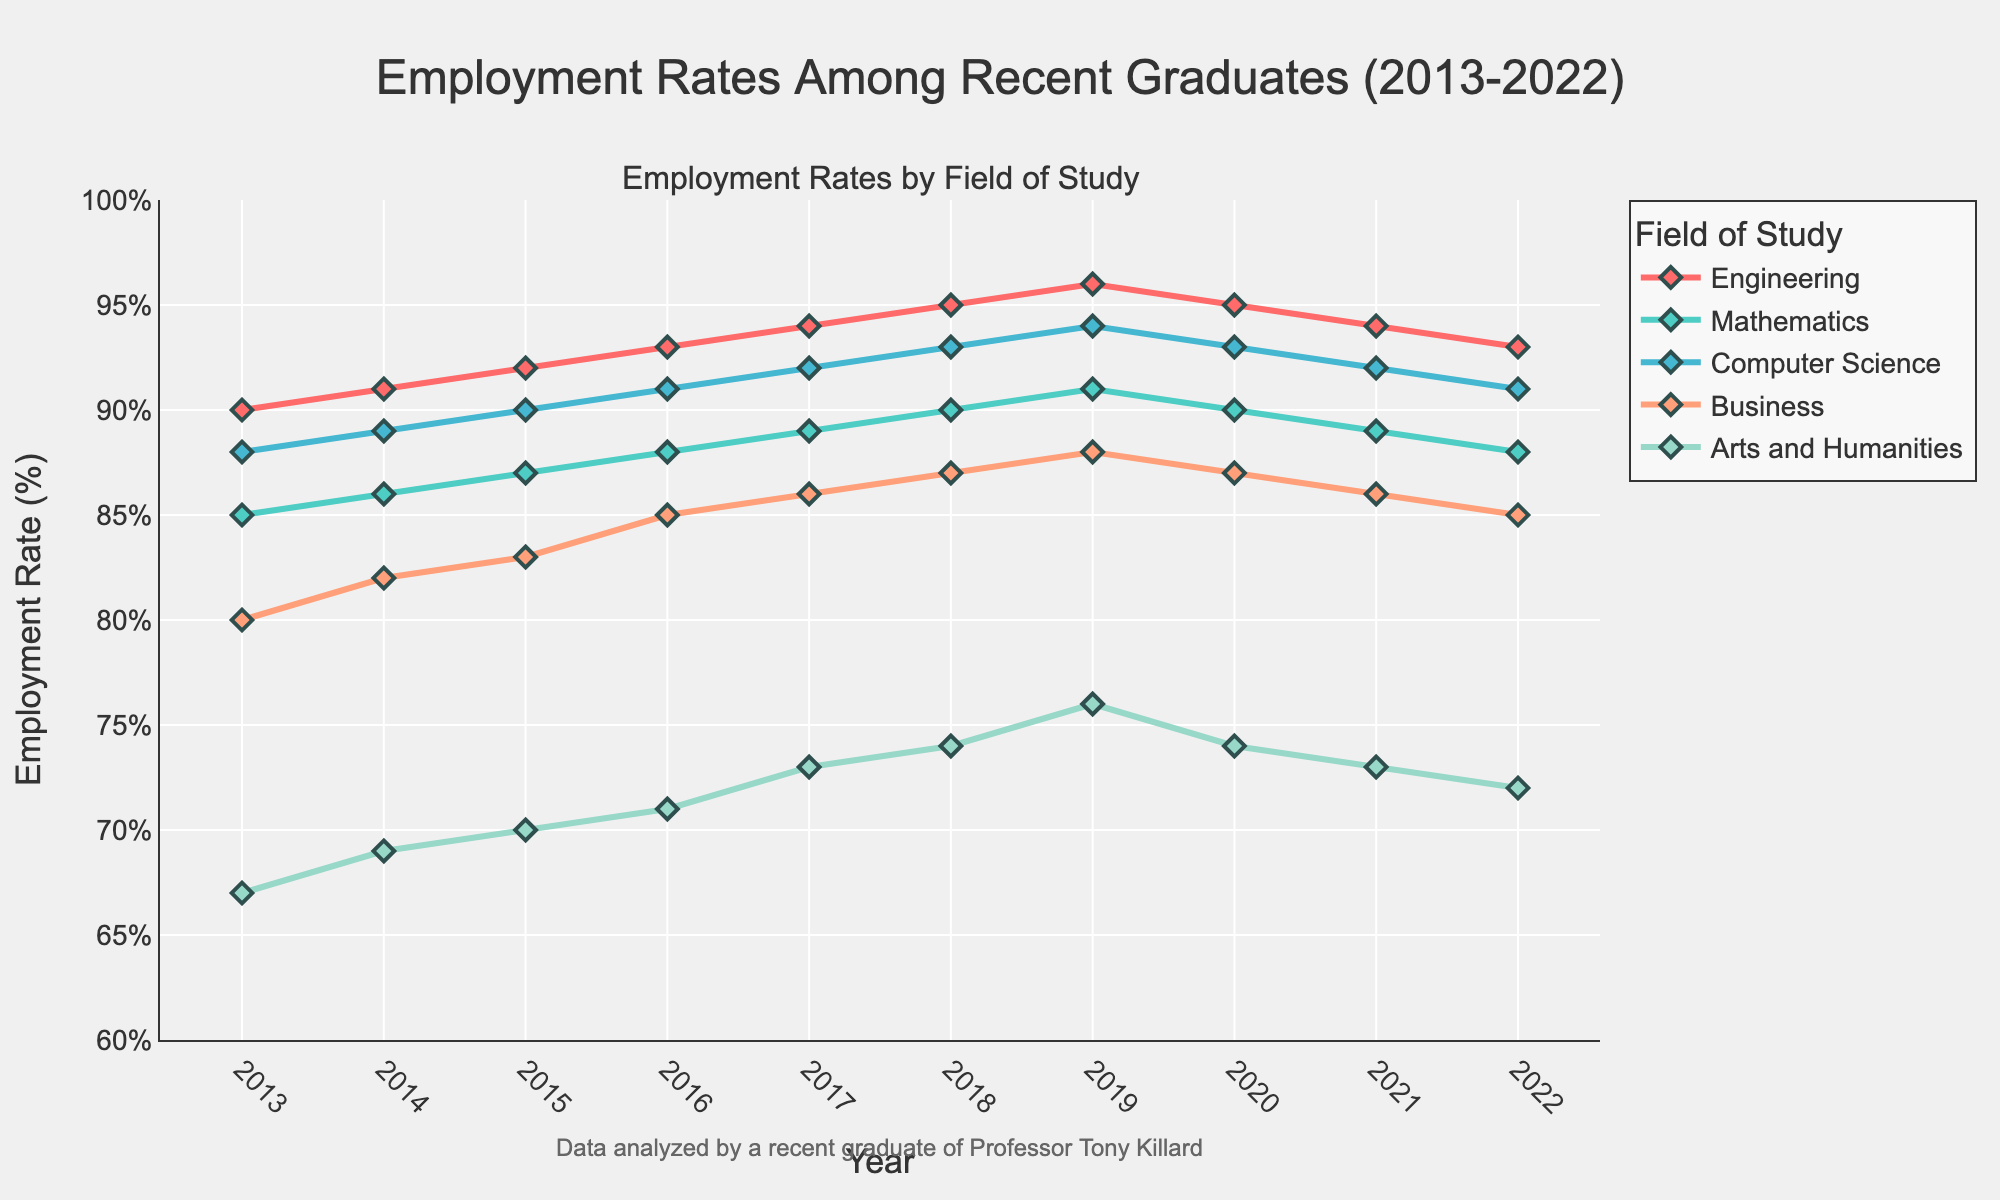What is the employment rate for Engineering graduates in 2022? Look on the plot for the data point corresponding to Engineering in the year 2022.
Answer: 93% How did the employment rate for Business graduates change from 2013 to 2022? Find the employment rate for Business in both 2013 and 2022 and calculate the difference. In 2013, it was 80%, and in 2022, it was 85%. The change is 85% - 80% = 5%.
Answer: Increased by 5% Between Mathematics and Computer Science, which field had a higher employment rate in 2015? Locate the points for Mathematics and Computer Science in 2015. Mathematics had an employment rate of 87%, and Computer Science had 90%.
Answer: Computer Science What is the average employment rate for Arts and Humanities over the entire period? Sum the employment rates for Arts and Humanities from 2013 to 2022 and divide by the number of years, which is 10. (67+69+70+71+73+74+76+74+73+72) / 10 = 71.9
Answer: 71.9% What year did Computer Science graduates experience their highest employment rate? Look for the peak of the Computer Science line on the plot. The highest point is in 2019 or 2020 with an employment rate of 94%.
Answer: 2019 Which field of study shows the most consistent upward trend in employment rates? Look at all the lines and determine which one shows a steady increase over time. The Engineering line consistently grows. Compare with other fields.
Answer: Engineering What is the difference between the highest and lowest employment rates for Arts and Humanities graduates over the decade? Identify the highest and lowest points on the Arts and Humanities line: highest is 76% (2019), and lowest is 67% (2013). The difference is 76% - 67% = 9%.
Answer: 9% How did the pandemic year 2020 affect employment rates across different fields? Inspect the employment rates for the year 2020 for all fields. Compare these with 2019 to see any declines. Most fields, such as Engineering and Business, show a slight decline.
Answer: Slight decline In which year did Business graduates have the highest employment rate, and what was it? Scan the Business line to identify the peak point, which is in 2019 with an employment rate of 88%.
Answer: 2019, 88% Which field experienced the largest increase in employment rate from one year to the next, and what was the increase? Check year-over-year changes for all fields. Computer Science from 2013 (88%) to 2014 (89%) is 1%, but Engineering from 2018 (95%) to 2019 (96%) is 1%, Business from 2017 (86%) to 2018 (87%) is 1%. The largest step change is in Mathematics from 2014 (86%) to 2015 (87%) is 1%.
Answer: Engineering, 1% 